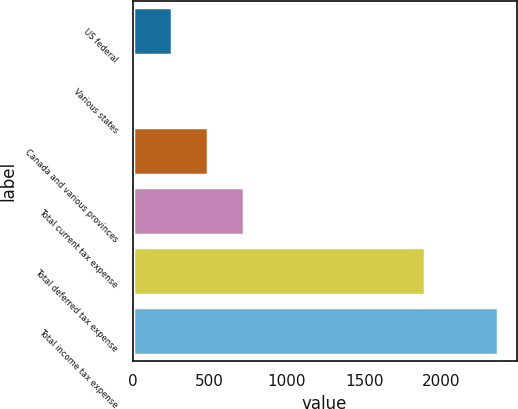<chart> <loc_0><loc_0><loc_500><loc_500><bar_chart><fcel>US federal<fcel>Various states<fcel>Canada and various provinces<fcel>Total current tax expense<fcel>Total deferred tax expense<fcel>Total income tax expense<nl><fcel>253<fcel>18<fcel>488<fcel>723<fcel>1891<fcel>2368<nl></chart> 